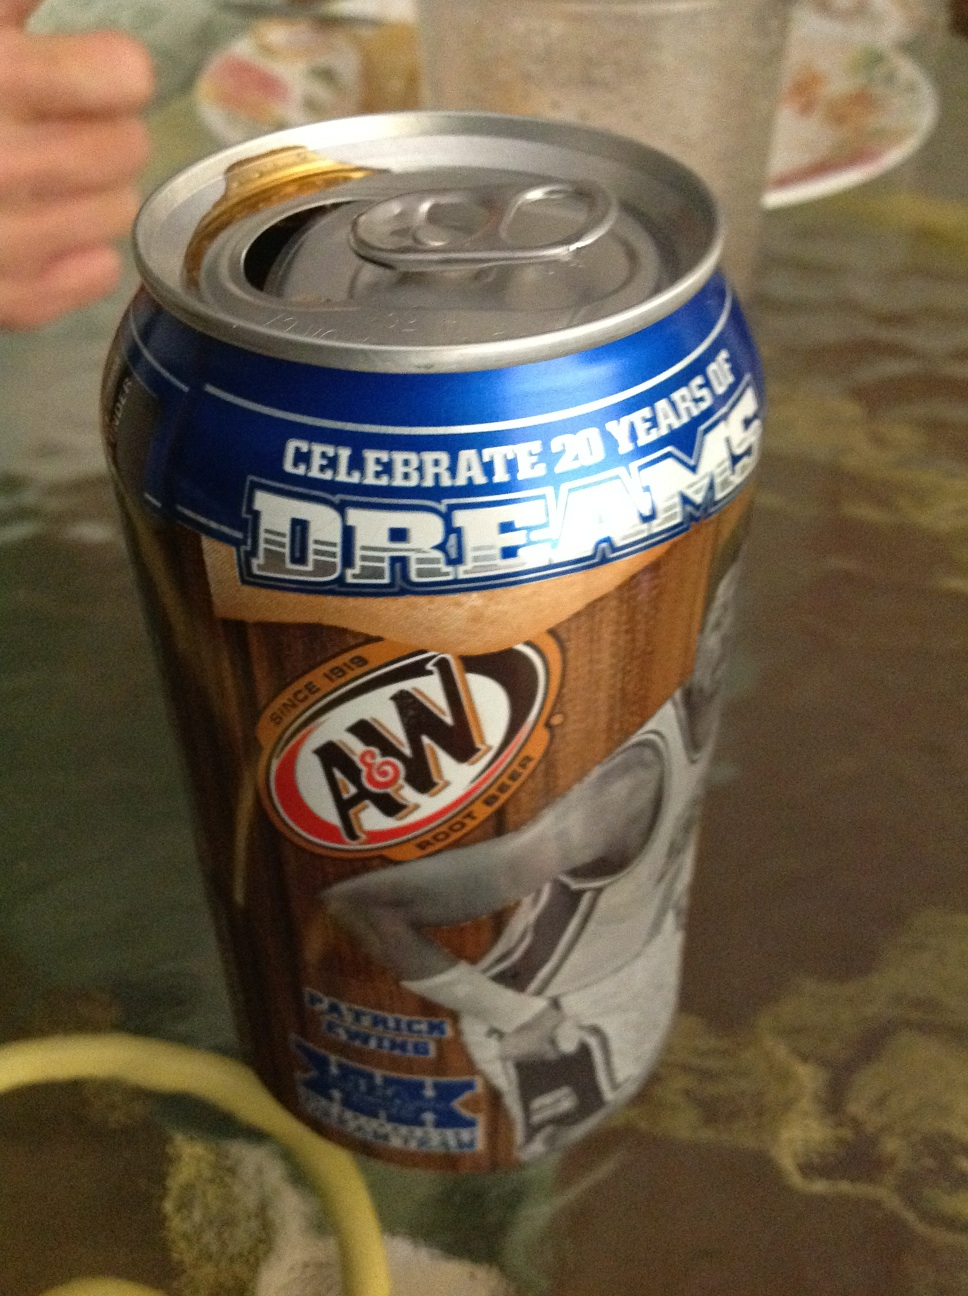What special edition is being celebrated on this can? This can is celebrating 20 years of dreams, which is likely a special campaign or promotion by A&W. The can features imagery and text associated with this celebration. 